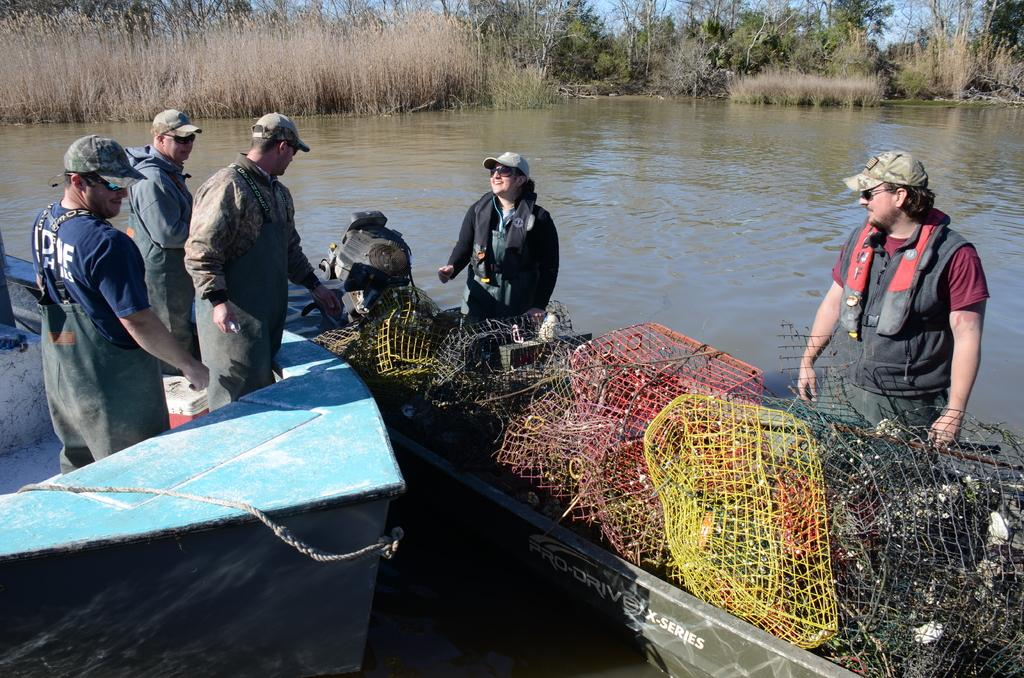How many boats are in the image? There are two boats in the image. Are there any people in the boats? Yes, there are people in the boats. What else can be seen in the image besides the boats and people? There are other objects in the image. What is visible in the background of the image? There are trees and water visible in the background of the image. What type of steam is coming out of the boats in the image? There is no steam coming out of the boats in the image. Can you see any rats on the boats or in the water? There are no rats visible in the image. 